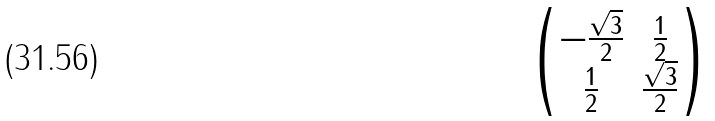<formula> <loc_0><loc_0><loc_500><loc_500>\begin{pmatrix} - \frac { \sqrt { 3 } } { 2 } & \frac { 1 } { 2 } \\ \frac { 1 } { 2 } & \frac { \sqrt { 3 } } { 2 } \\ \end{pmatrix}</formula> 